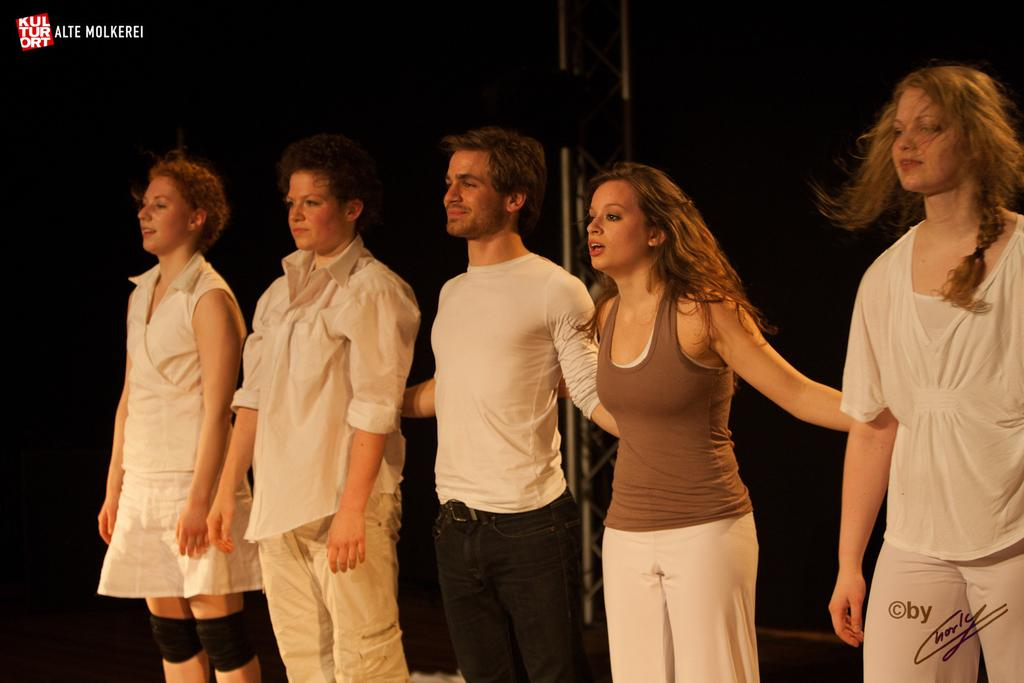How many people are present in the image? There are five persons standing in the image. What is located behind the people in the image? There is a truss behind the people. What is the color of the background in the image? The background of the image is dark. Are there any visible marks on the image itself? Yes, there are watermarks on the image. How many cars can be seen in the image? There are no cars visible in the image. What type of pet is sitting next to the people in the image? There are no pets present in the image. 